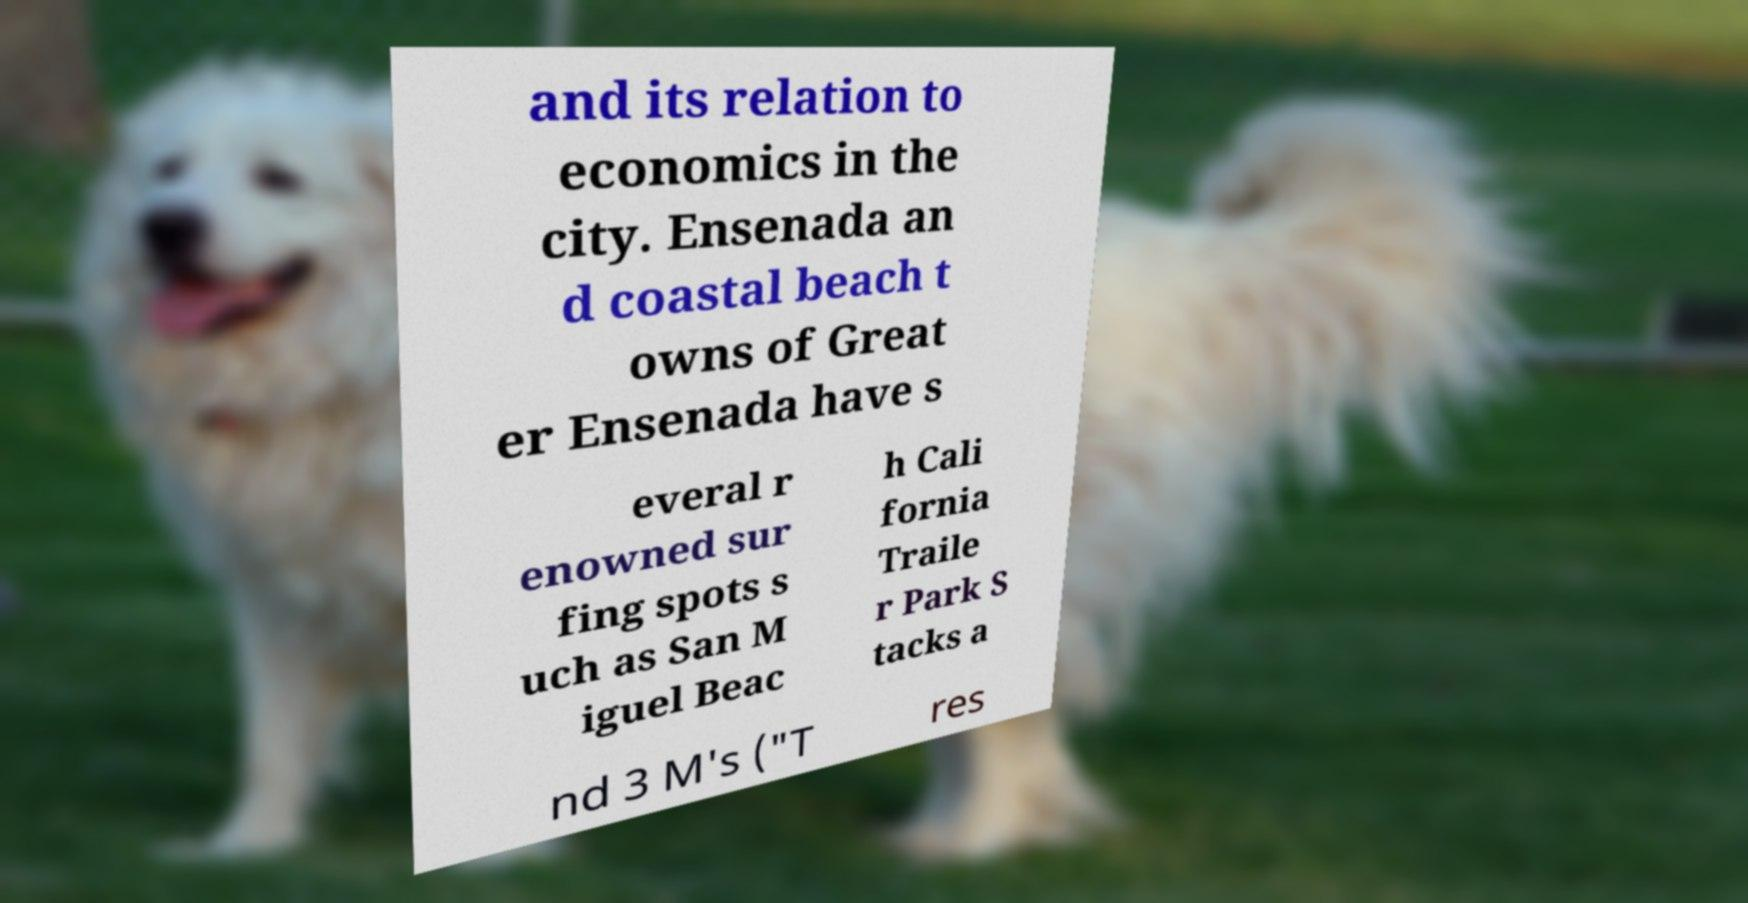There's text embedded in this image that I need extracted. Can you transcribe it verbatim? and its relation to economics in the city. Ensenada an d coastal beach t owns of Great er Ensenada have s everal r enowned sur fing spots s uch as San M iguel Beac h Cali fornia Traile r Park S tacks a nd 3 M's ("T res 